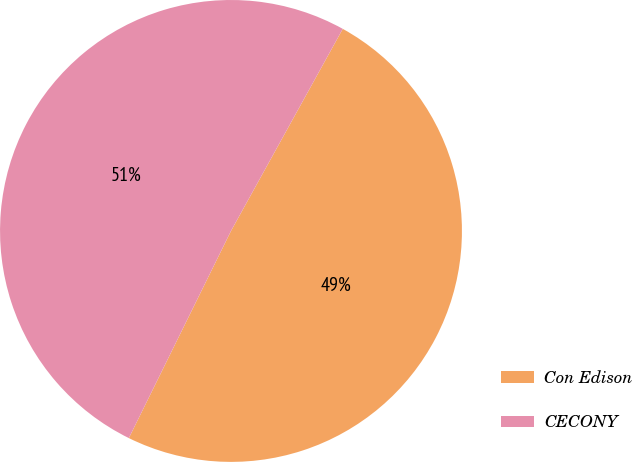<chart> <loc_0><loc_0><loc_500><loc_500><pie_chart><fcel>Con Edison<fcel>CECONY<nl><fcel>49.25%<fcel>50.75%<nl></chart> 